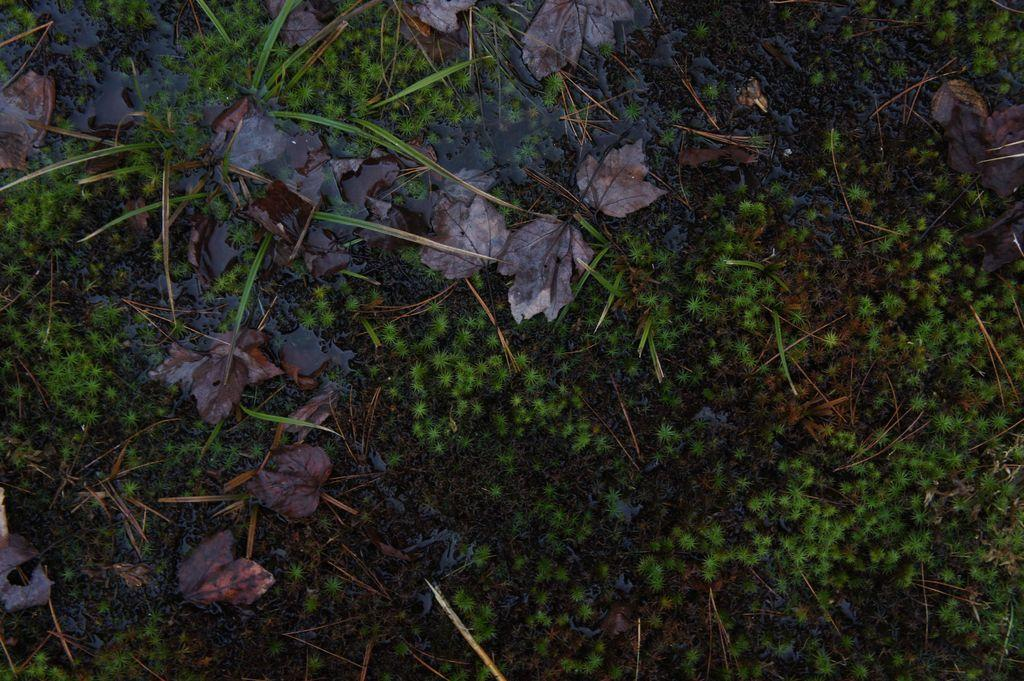What type of surface can be seen in the image? The ground is visible in the image. What type of vegetation is present in the image? There is grass in the image. What additional elements can be found on the ground in the image? Dried leaves are present in the image. What type of cork can be seen in the image? There is no cork present in the image. 